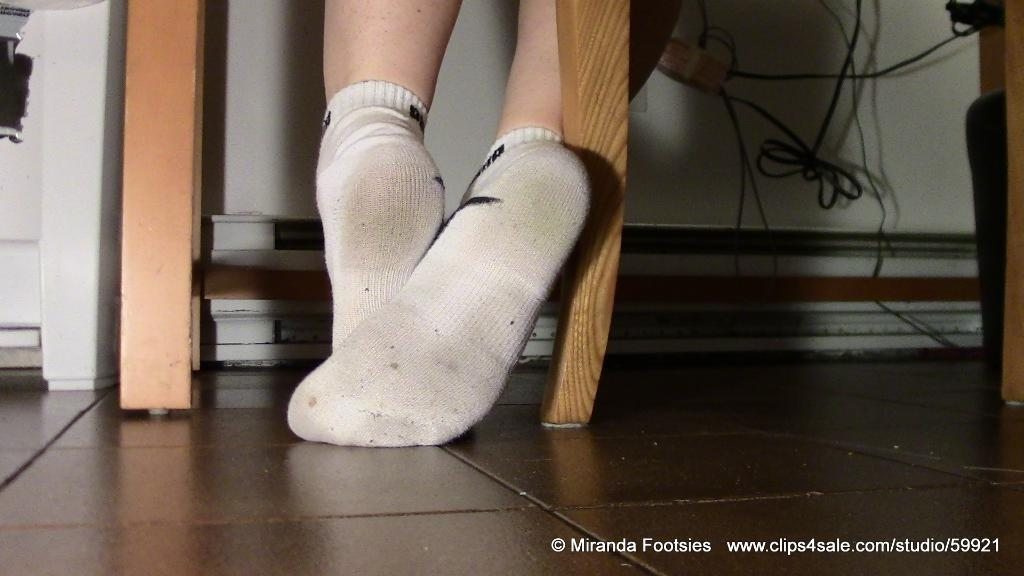What part of a person can be seen in the image? There are legs of a person visible in the image. What type of surface is the person standing on? The floor is visible in the image. What can be seen in the background of the image? There is a wall in the background of the image. How many bikes are being ridden by the person in the image? There are no bikes present in the image; only the legs of a person are visible. What level of expertise does the person have in using a wing in the image? There is no wing present in the image, so it is not possible to determine the person's level of expertise. 